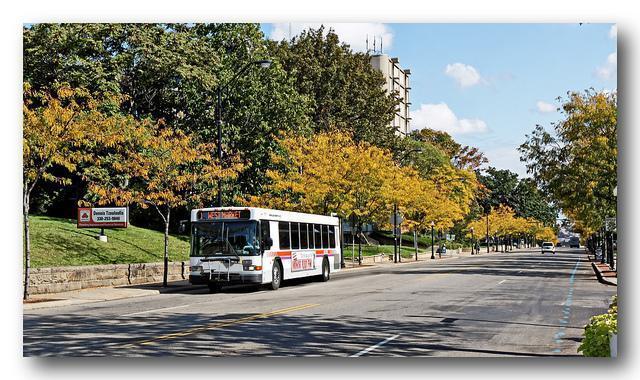How many orange cups are on the table?
Give a very brief answer. 0. 